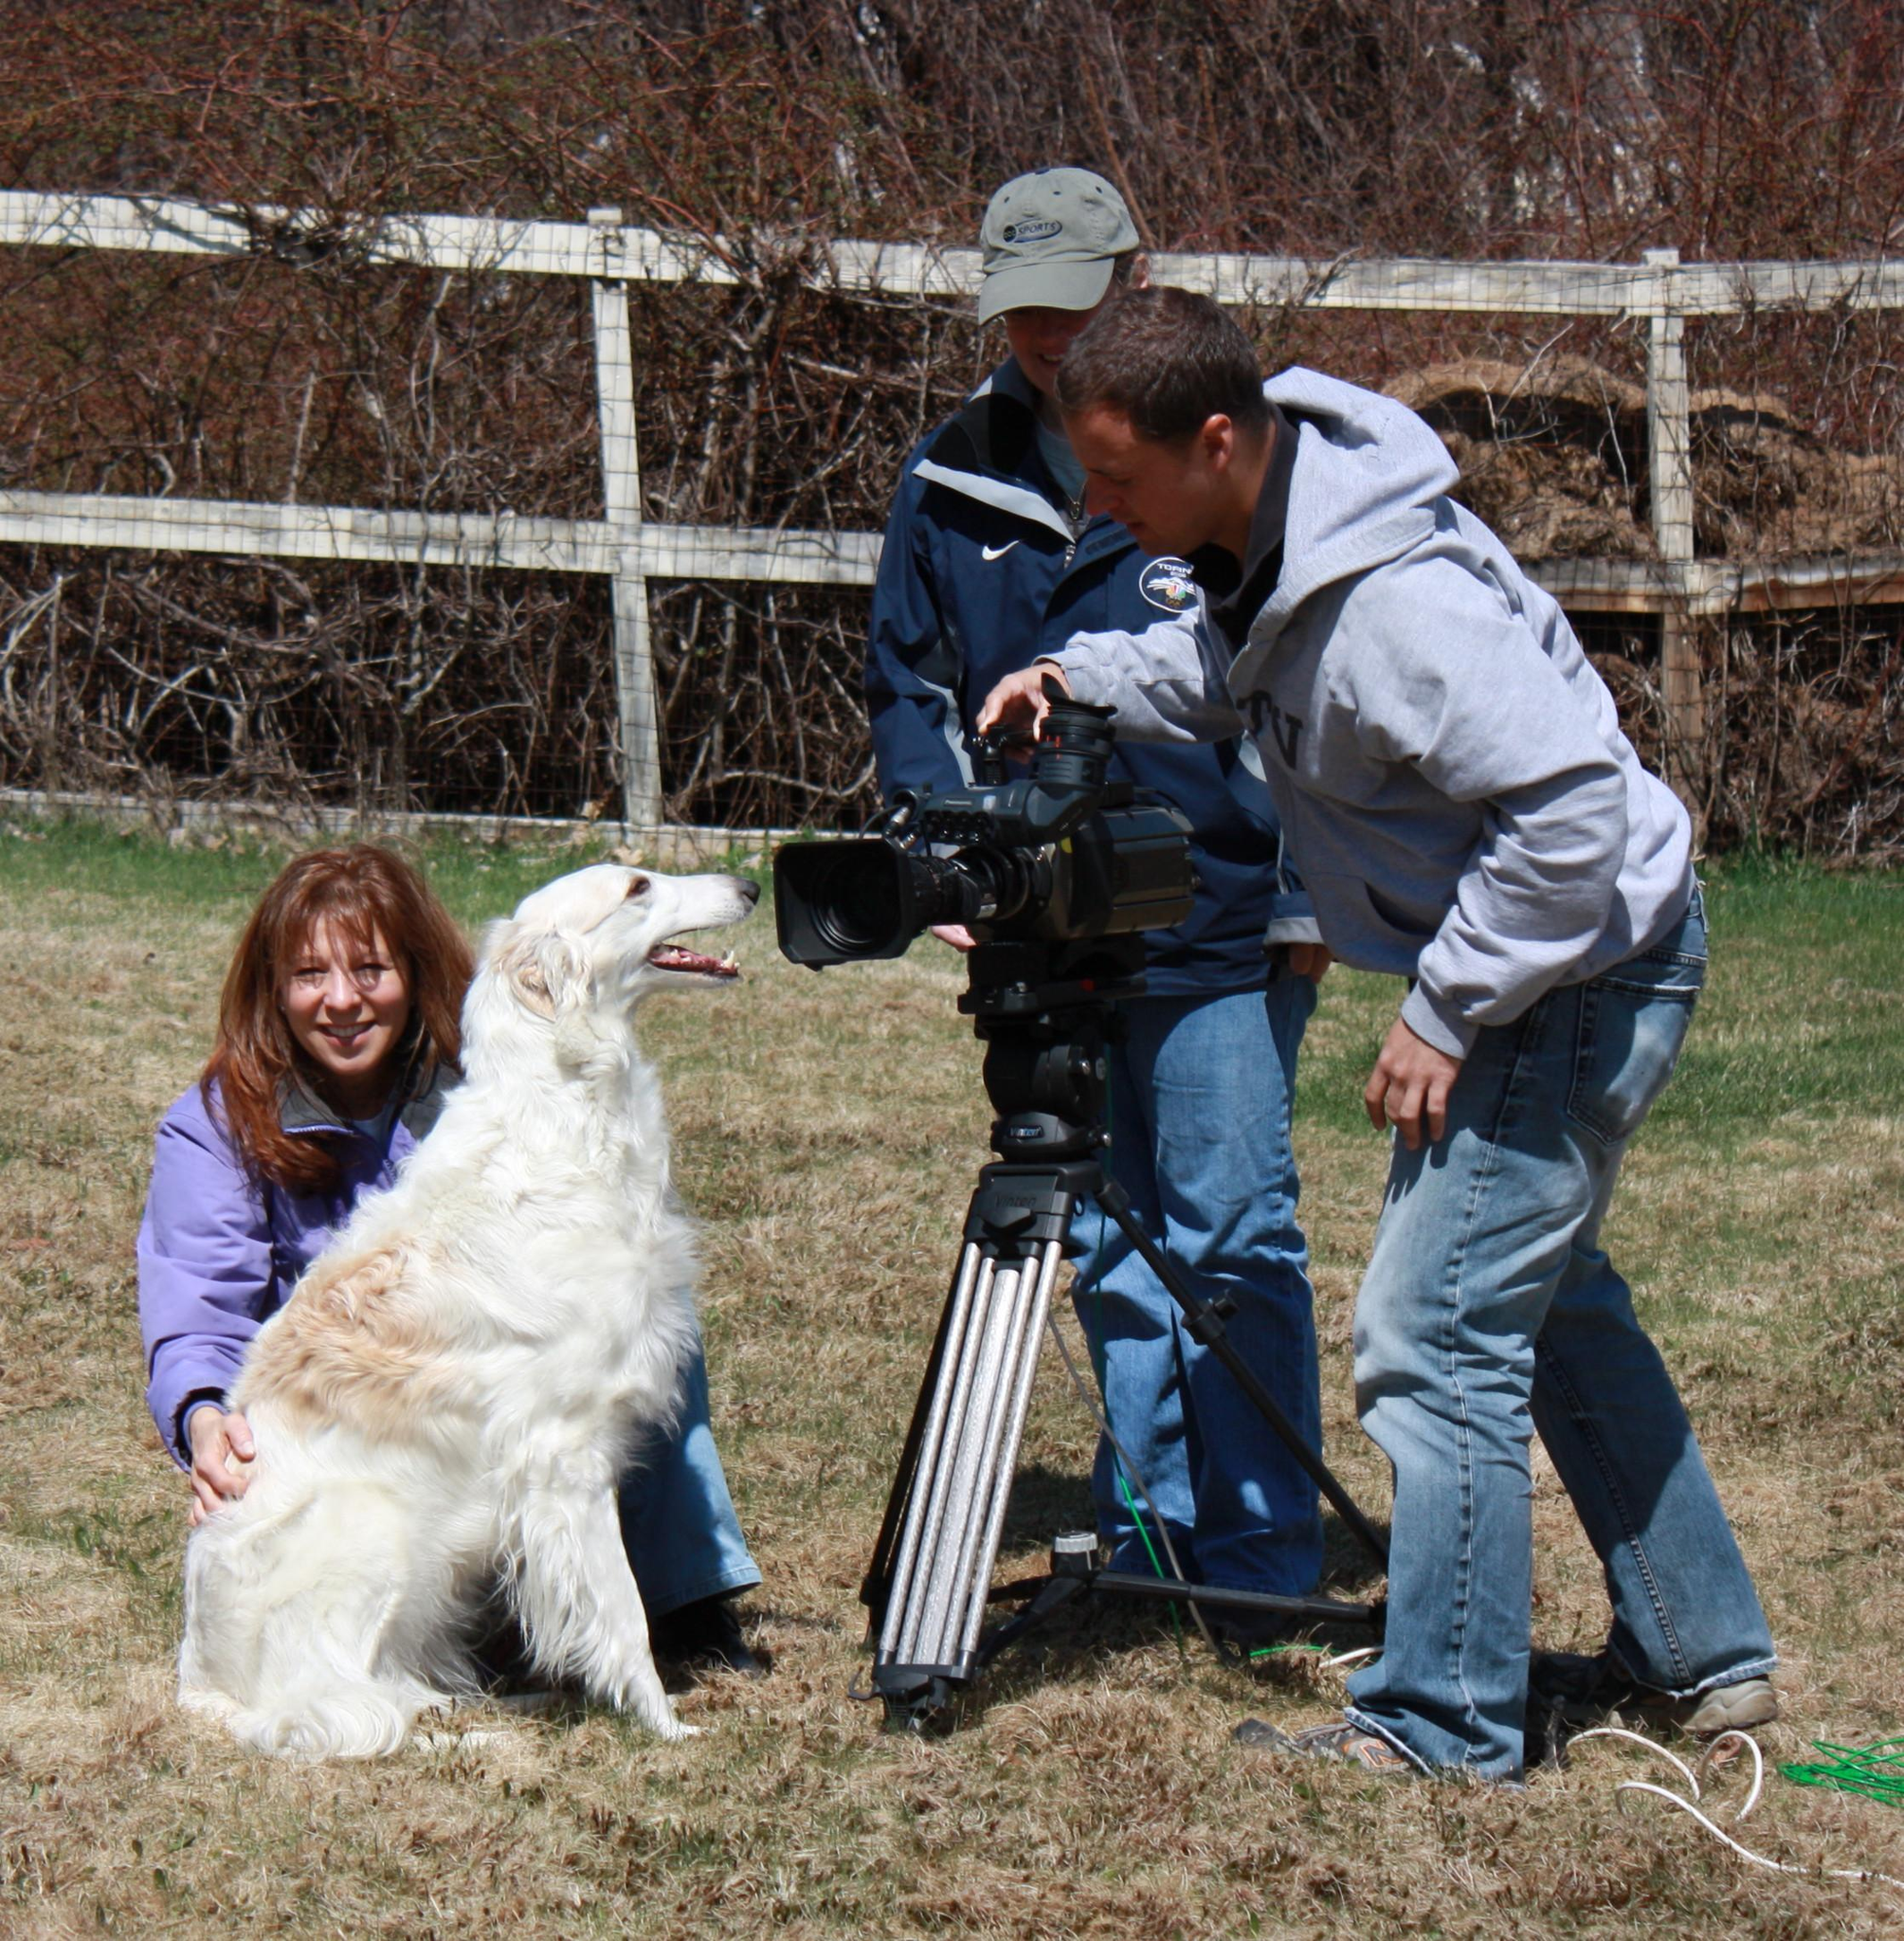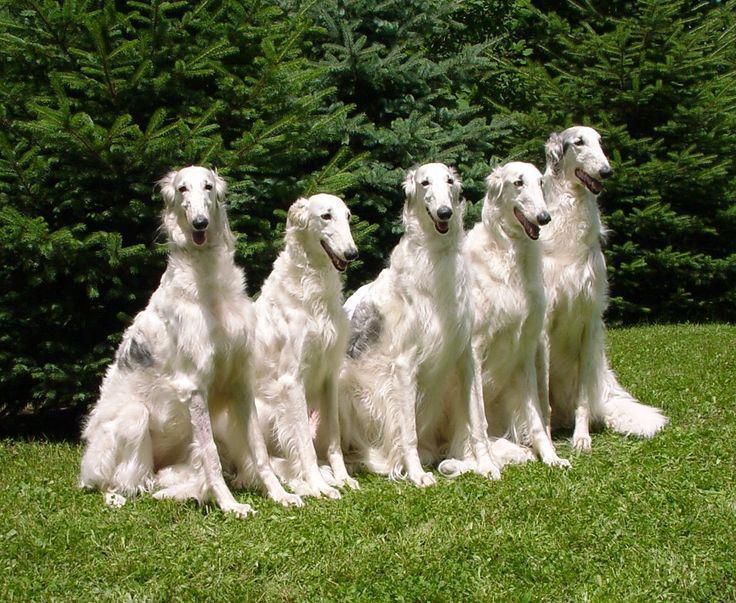The first image is the image on the left, the second image is the image on the right. Assess this claim about the two images: "An image shows at least three hounds sitting upright in a row on green grass.". Correct or not? Answer yes or no. Yes. The first image is the image on the left, the second image is the image on the right. Given the left and right images, does the statement "There are four dogs in total." hold true? Answer yes or no. No. 